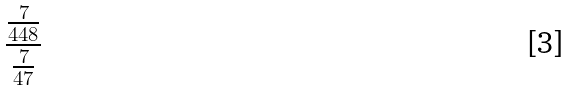<formula> <loc_0><loc_0><loc_500><loc_500>\frac { \frac { 7 } { 4 4 8 } } { \frac { 7 } { 4 7 } }</formula> 